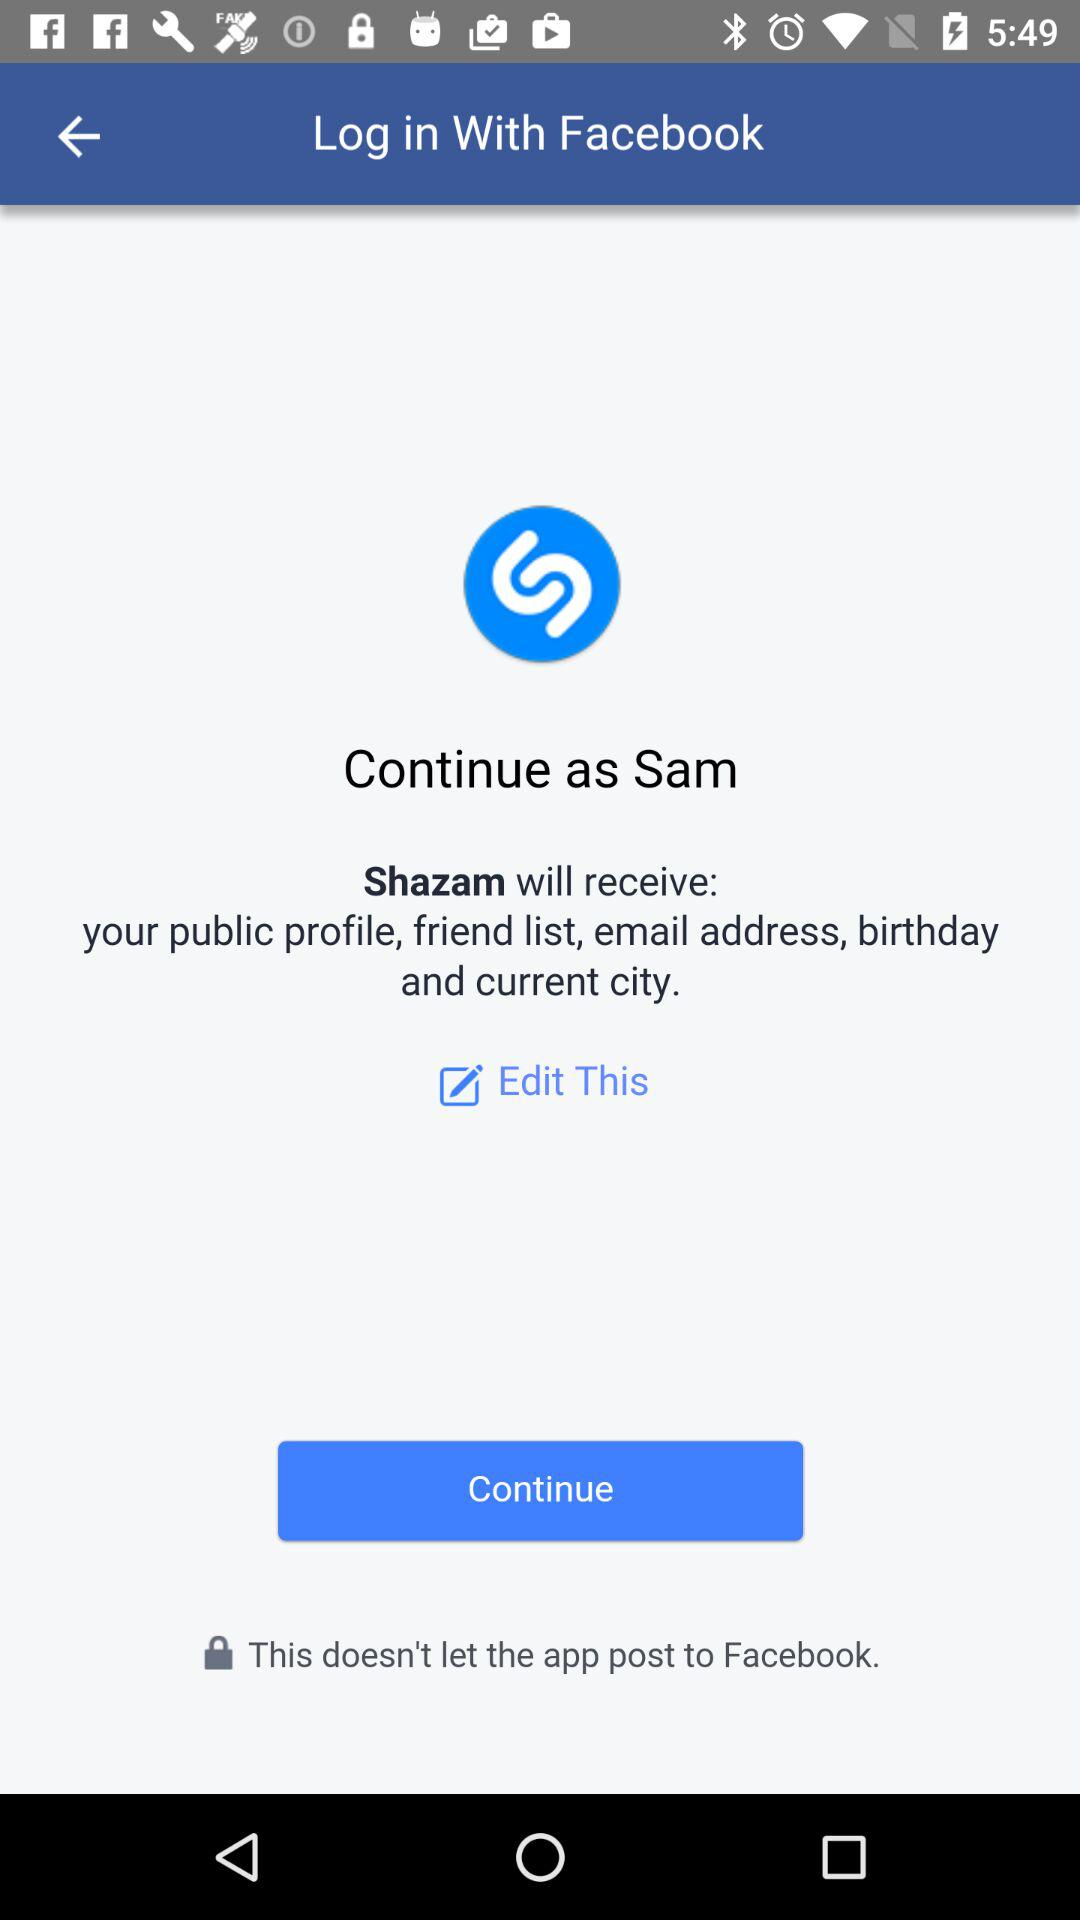What application are we accessing? You are accessing "Shazam". 